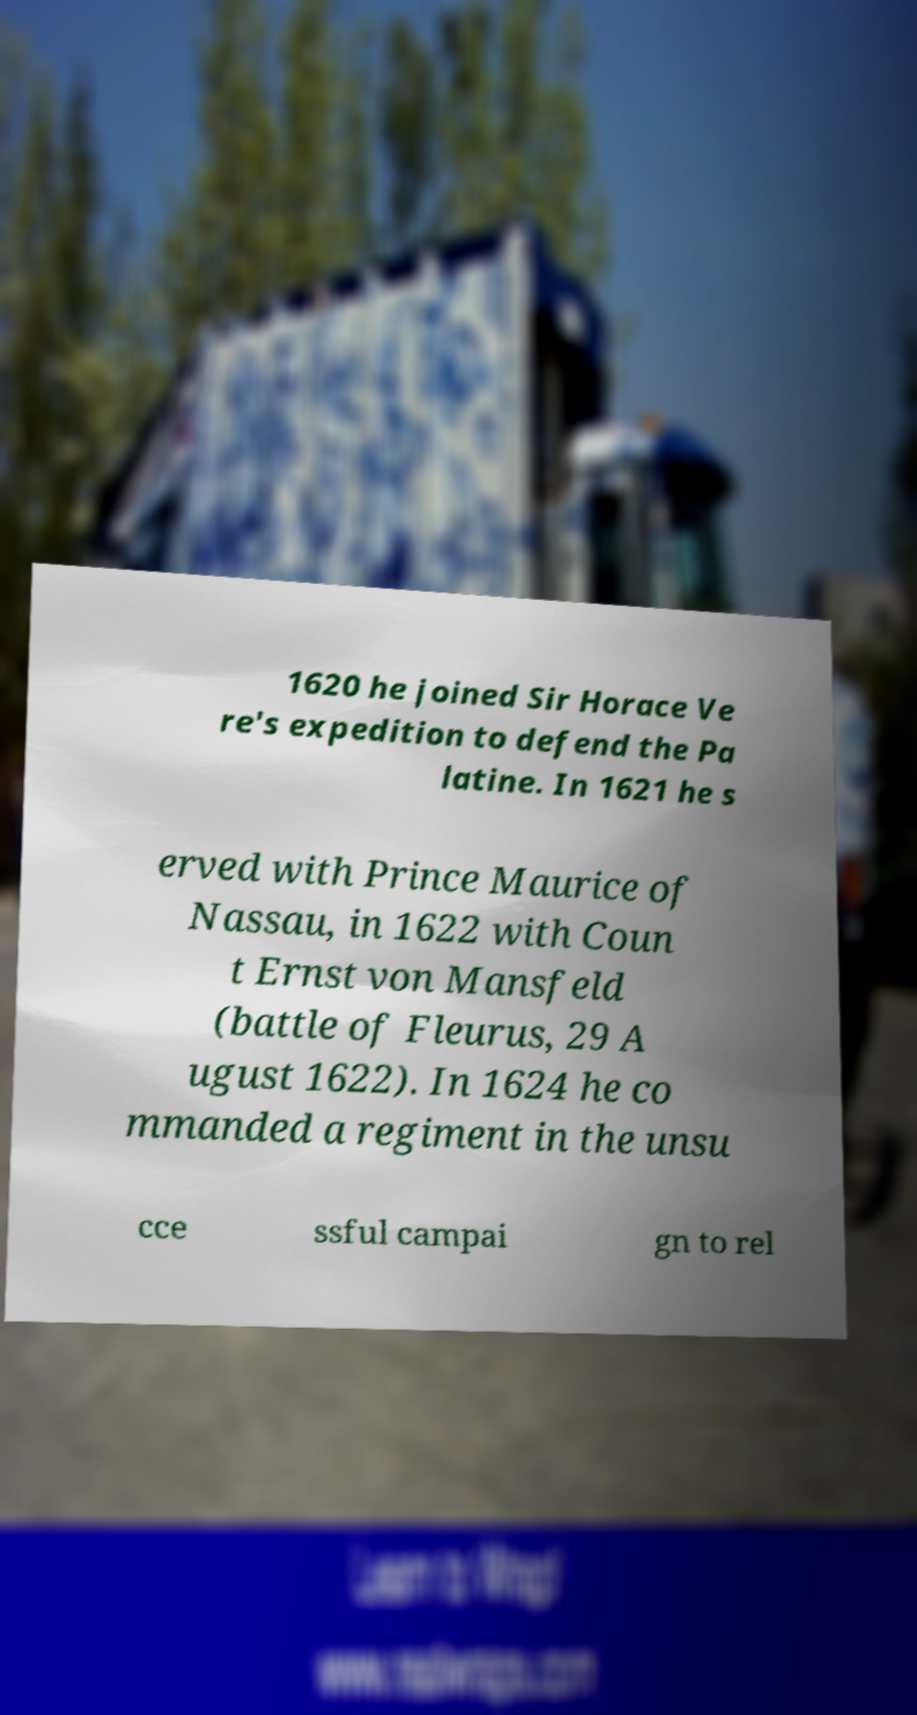Can you accurately transcribe the text from the provided image for me? 1620 he joined Sir Horace Ve re's expedition to defend the Pa latine. In 1621 he s erved with Prince Maurice of Nassau, in 1622 with Coun t Ernst von Mansfeld (battle of Fleurus, 29 A ugust 1622). In 1624 he co mmanded a regiment in the unsu cce ssful campai gn to rel 